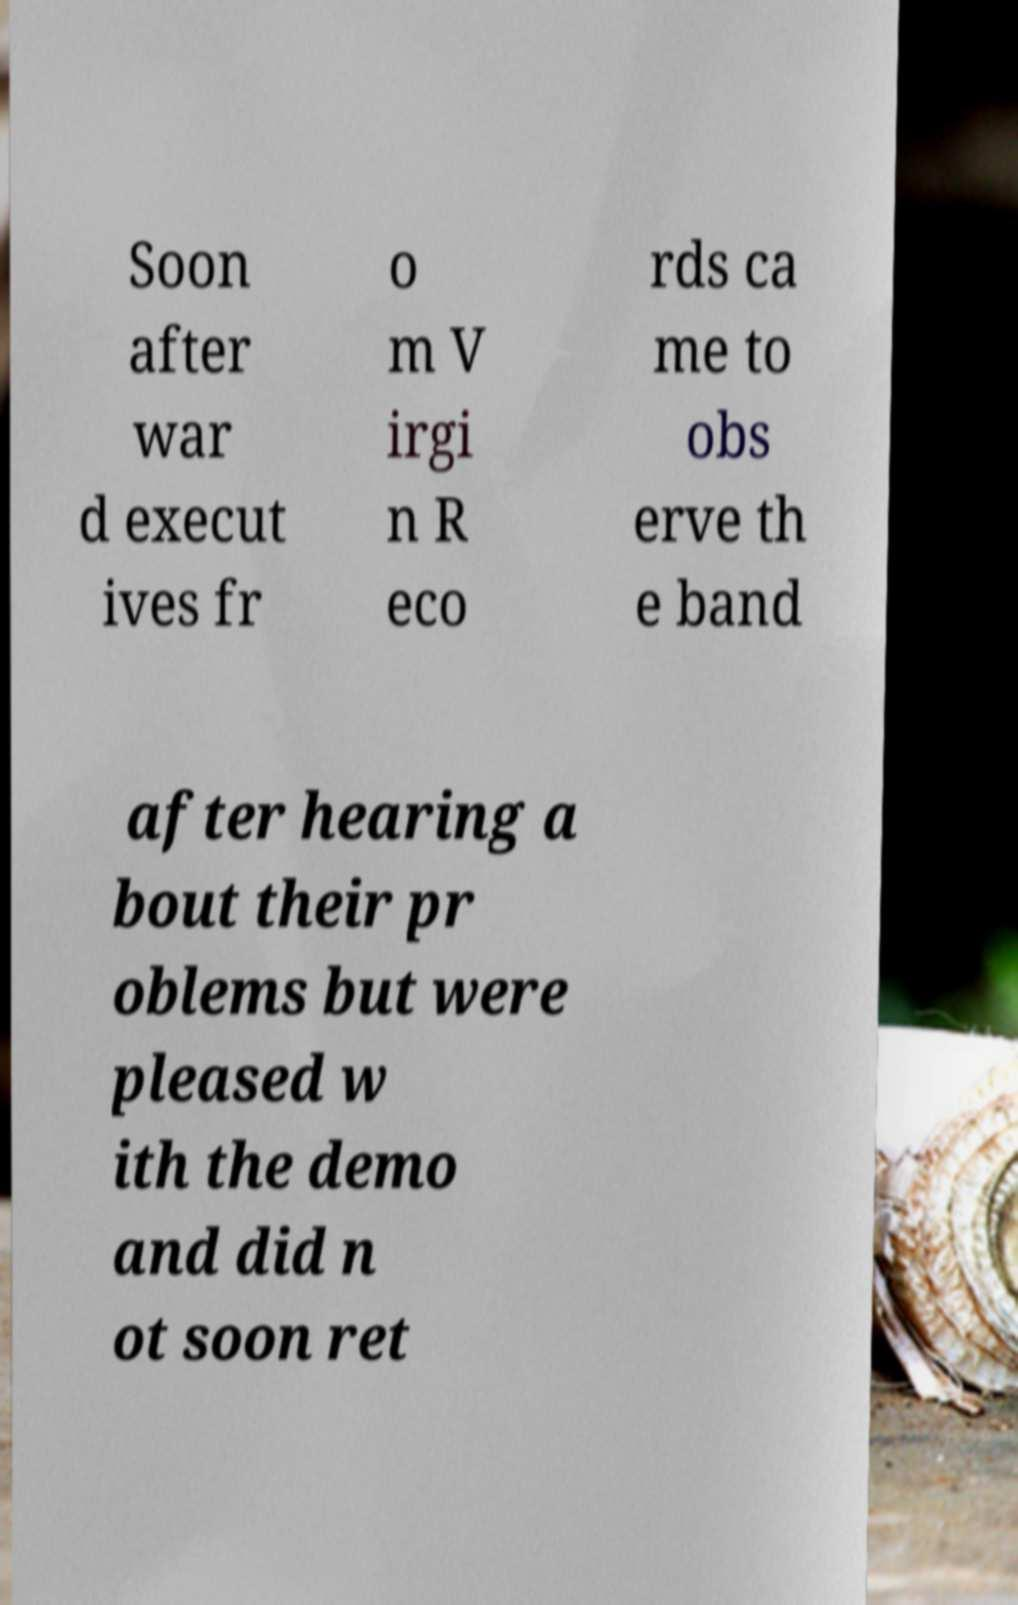I need the written content from this picture converted into text. Can you do that? Soon after war d execut ives fr o m V irgi n R eco rds ca me to obs erve th e band after hearing a bout their pr oblems but were pleased w ith the demo and did n ot soon ret 